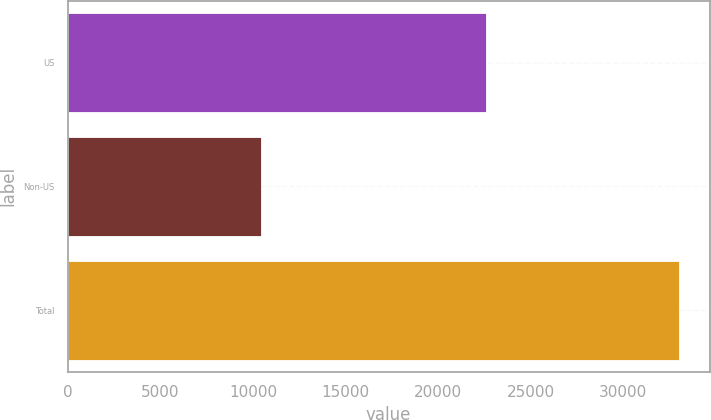Convert chart to OTSL. <chart><loc_0><loc_0><loc_500><loc_500><bar_chart><fcel>US<fcel>Non-US<fcel>Total<nl><fcel>22565<fcel>10441<fcel>33006<nl></chart> 